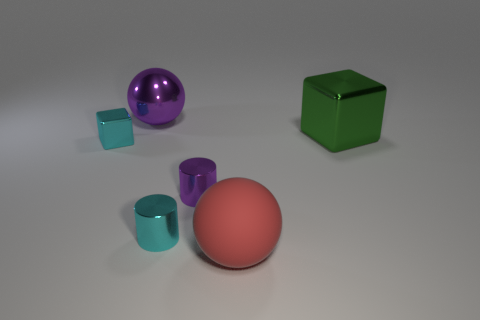What number of things are either tiny objects that are in front of the small purple object or small green shiny balls?
Make the answer very short. 1. Is the shape of the red matte object the same as the large purple object?
Provide a succinct answer. Yes. What is the color of the large block?
Provide a succinct answer. Green. What number of tiny things are green cubes or red matte objects?
Ensure brevity in your answer.  0. Is the size of the cube that is right of the red ball the same as the purple metal thing that is behind the large block?
Your answer should be compact. Yes. There is another object that is the same shape as the small purple metallic object; what size is it?
Give a very brief answer. Small. Is the number of blocks that are behind the metallic sphere greater than the number of blocks that are behind the red object?
Keep it short and to the point. No. There is a object that is on the right side of the tiny purple object and in front of the small purple cylinder; what material is it?
Your response must be concise. Rubber. What is the color of the small shiny object that is the same shape as the large green object?
Offer a terse response. Cyan. The cyan cylinder is what size?
Provide a short and direct response. Small. 